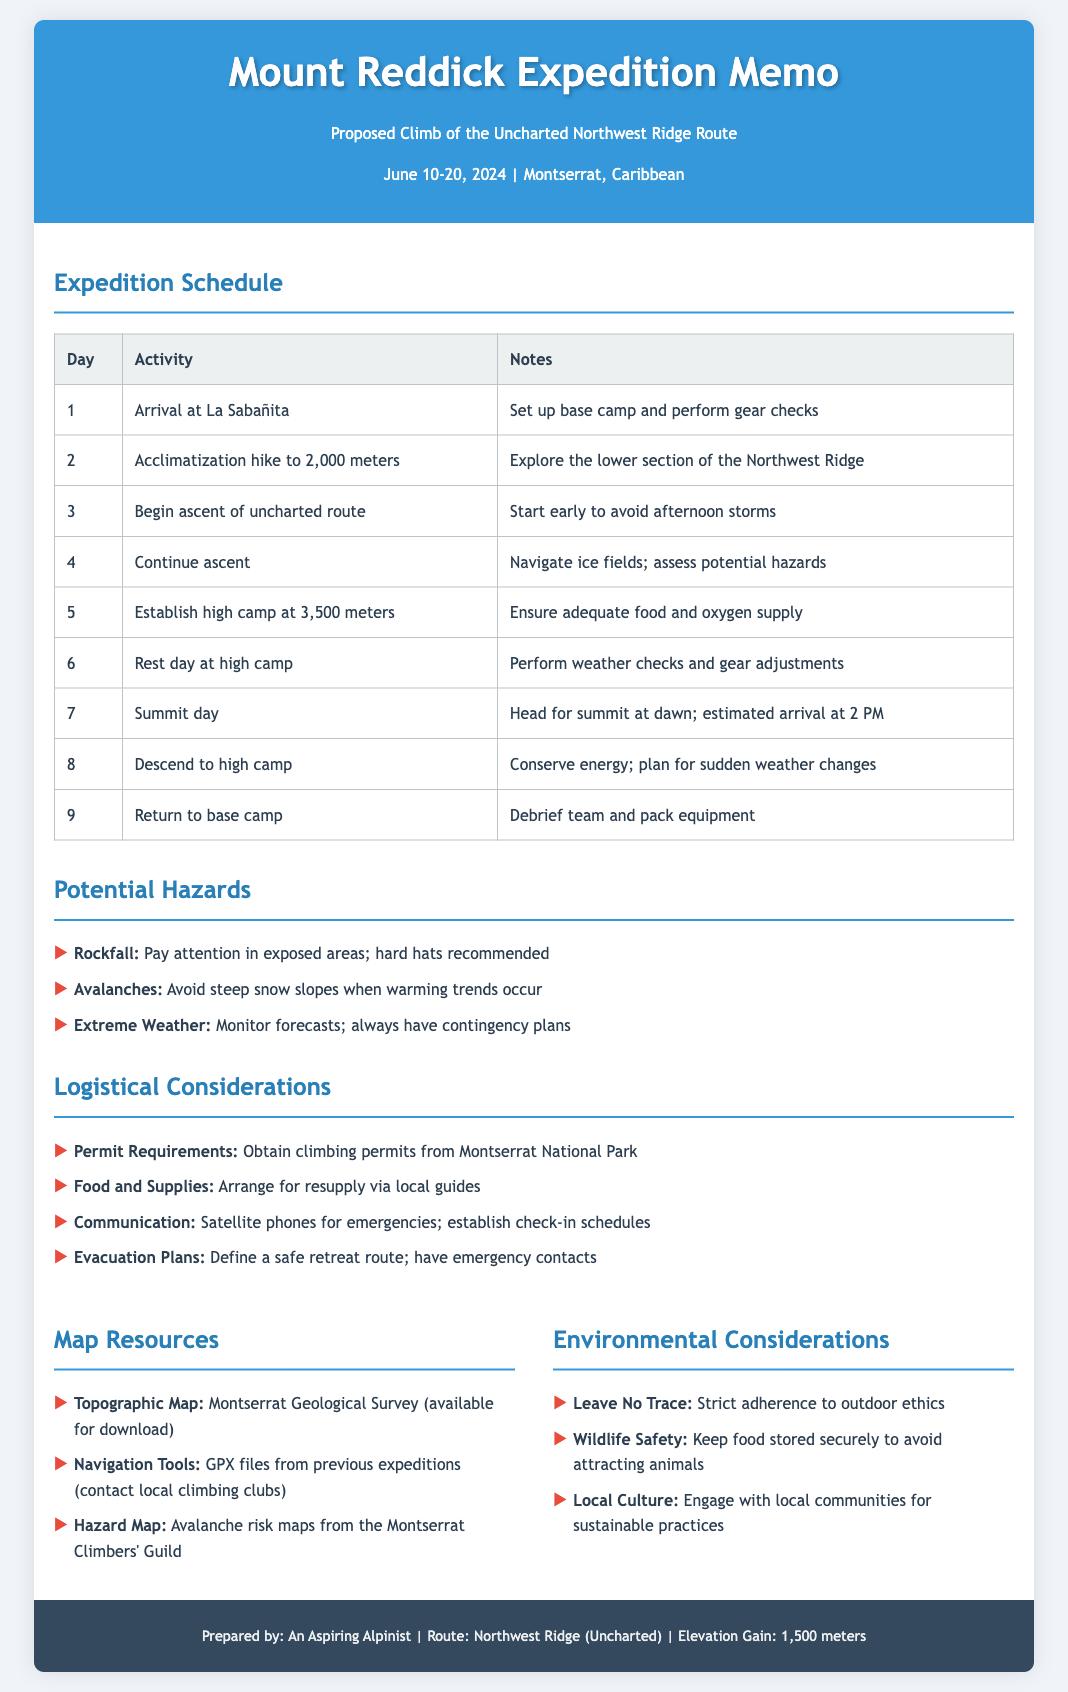What are the expedition dates? The expedition dates are clearly stated at the top of the document, indicating when the climb will take place.
Answer: June 10-20, 2024 What is the first activity planned for Day 1? The first activity on Day 1 is listed in the schedule section of the document, where it describes the arrival and setup.
Answer: Arrival at La Sabañita What is the elevation gain for the route? The elevation gain is specified in the footer, pointing to the climb's difficulty and altitude change.
Answer: 1,500 meters What communication tool is recommended for emergencies? The logistics section discusses this aspect, indicating the tools to use for safety and coordination during the climb.
Answer: Satellite phones What should climbers monitor due to extreme weather? The potential hazards section highlights the importance of being aware of weather conditions.
Answer: Forecasts What is the highest camp established during the climb? The schedule specifies the elevation at which the high camp is to be set up, indicating where climbers will rest.
Answer: 3,500 meters What is one of the considerations for food storage? The environmental considerations outline the necessity of secure food storage to protect wildlife and climbers.
Answer: Keep food stored securely What document is required for climbing? The logistics section explicates the necessary permits for legal climbing, particularly focusing on the region.
Answer: Climbing permits What day is the summit attempt scheduled? The schedule provides a clear indication of which day climbers will aim for the peak, marking it as a significant point in the itinerary.
Answer: Day 7 